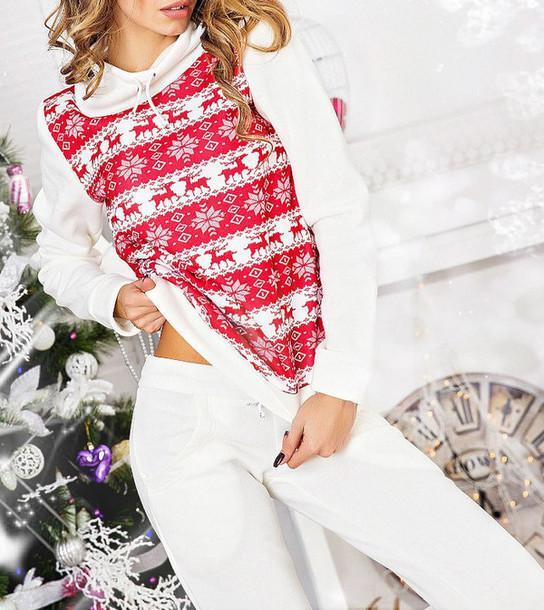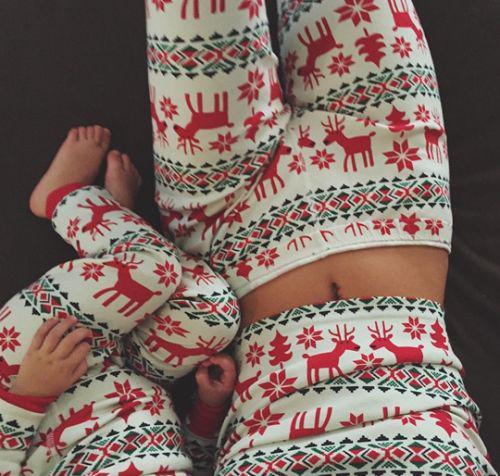The first image is the image on the left, the second image is the image on the right. Analyze the images presented: Is the assertion "The right image contains at least one person dressed in sleep attire." valid? Answer yes or no. Yes. The first image is the image on the left, the second image is the image on the right. Evaluate the accuracy of this statement regarding the images: "At least one pair of pajamas in both images feature a plaid bottom.". Is it true? Answer yes or no. No. 